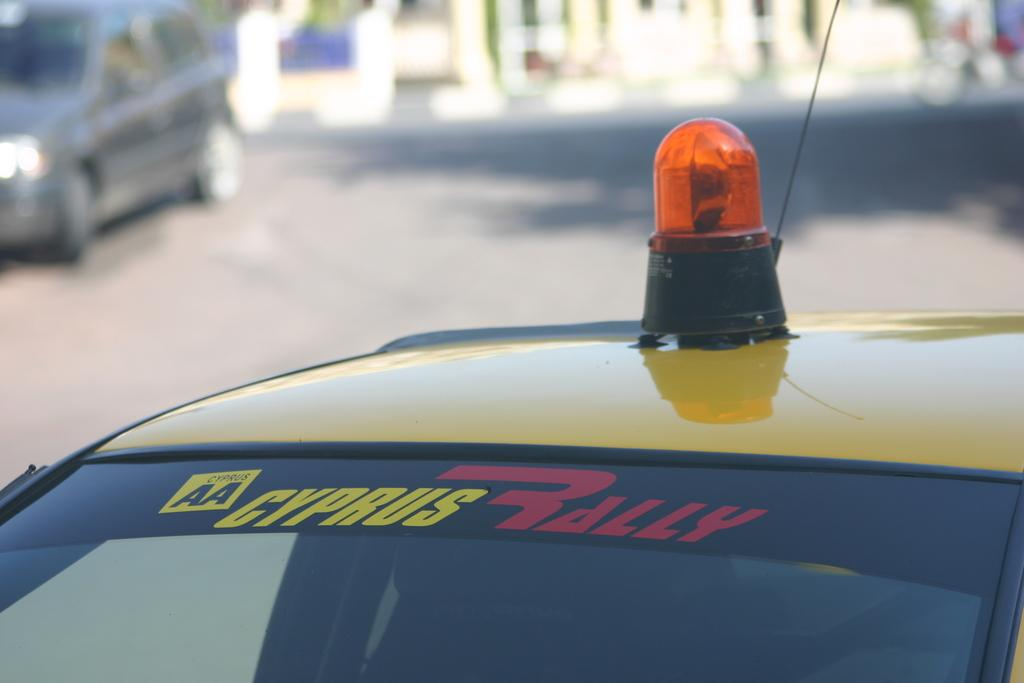<image>
Summarize the visual content of the image. a Cyprus Rally name on a vehicile of sorts. 